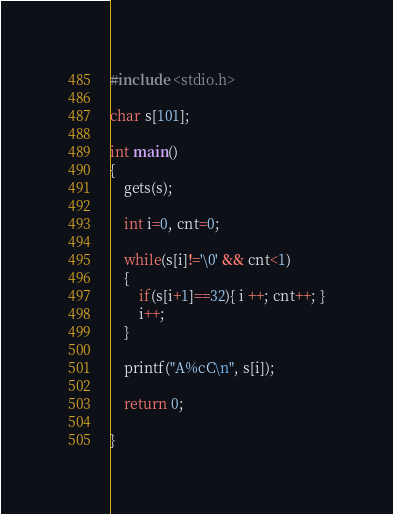<code> <loc_0><loc_0><loc_500><loc_500><_C++_>#include <stdio.h>

char s[101];

int main()
{
    gets(s);

    int i=0, cnt=0;

    while(s[i]!='\0' && cnt<1)
    {
        if(s[i+1]==32){ i ++; cnt++; }
        i++;
    }

    printf("A%cC\n", s[i]);

    return 0;

}
</code> 